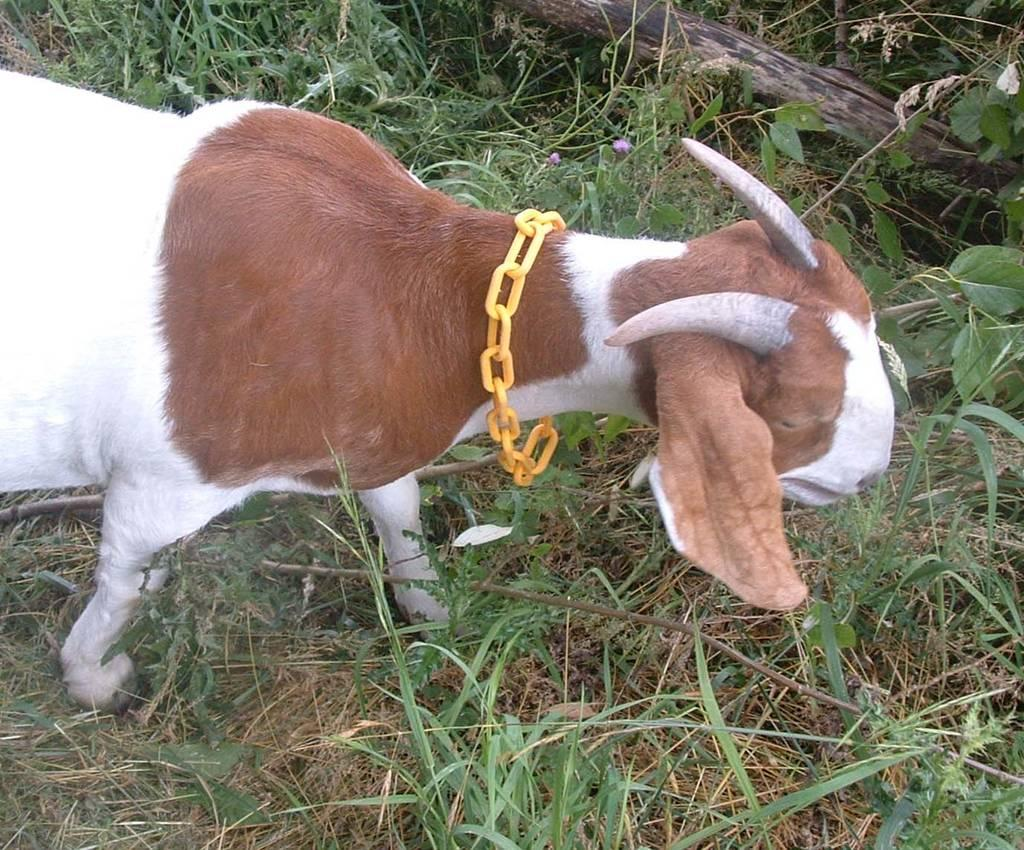What animal is standing in the image? There is a goat standing in the image. What is attached to the goat in the image? There is an iron chain in the image, which is yellow in color, and it is attached to the goat. What type of pole can be seen in the image? There appears to be a wooden pole in the image. What type of vegetation is visible in the image? There is grass visible in the image. What type of book is the goat reading in the image? There is no book present in the image, and the goat is not reading anything. 